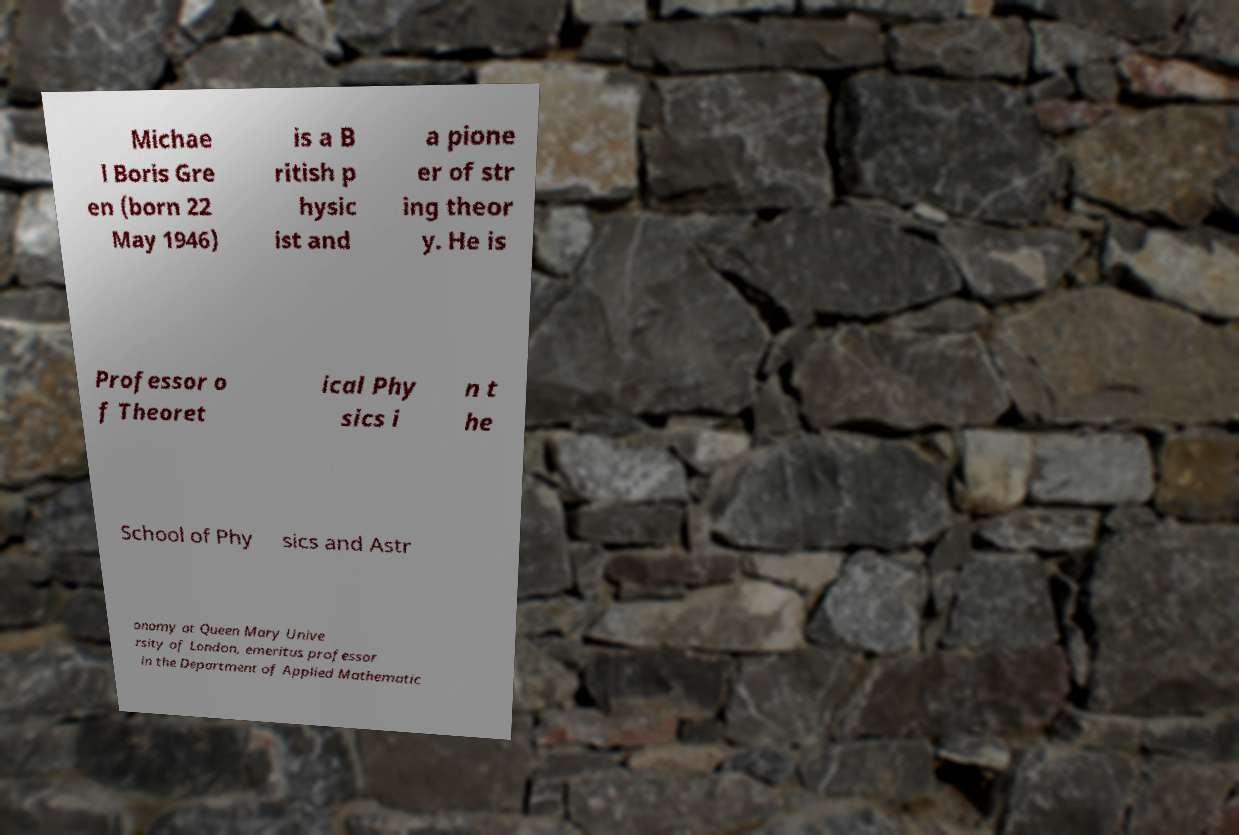Could you assist in decoding the text presented in this image and type it out clearly? Michae l Boris Gre en (born 22 May 1946) is a B ritish p hysic ist and a pione er of str ing theor y. He is Professor o f Theoret ical Phy sics i n t he School of Phy sics and Astr onomy at Queen Mary Unive rsity of London, emeritus professor in the Department of Applied Mathematic 